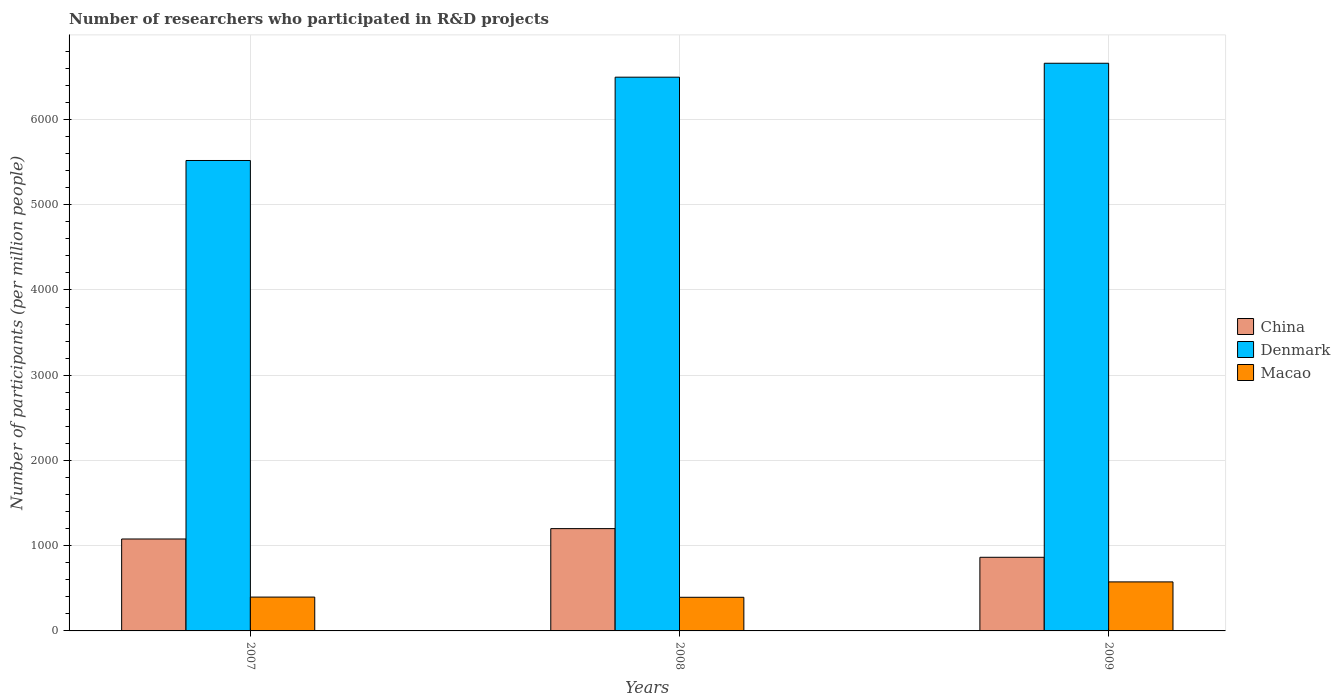How many different coloured bars are there?
Your response must be concise. 3. Are the number of bars on each tick of the X-axis equal?
Offer a terse response. Yes. What is the label of the 2nd group of bars from the left?
Your answer should be compact. 2008. What is the number of researchers who participated in R&D projects in Macao in 2009?
Provide a short and direct response. 575.18. Across all years, what is the maximum number of researchers who participated in R&D projects in China?
Provide a succinct answer. 1200.29. Across all years, what is the minimum number of researchers who participated in R&D projects in China?
Keep it short and to the point. 863.93. In which year was the number of researchers who participated in R&D projects in China maximum?
Make the answer very short. 2008. What is the total number of researchers who participated in R&D projects in Denmark in the graph?
Ensure brevity in your answer.  1.87e+04. What is the difference between the number of researchers who participated in R&D projects in Macao in 2007 and that in 2008?
Your answer should be very brief. 2.28. What is the difference between the number of researchers who participated in R&D projects in China in 2007 and the number of researchers who participated in R&D projects in Macao in 2009?
Keep it short and to the point. 503.45. What is the average number of researchers who participated in R&D projects in China per year?
Give a very brief answer. 1047.62. In the year 2009, what is the difference between the number of researchers who participated in R&D projects in Denmark and number of researchers who participated in R&D projects in China?
Your answer should be very brief. 5796.22. What is the ratio of the number of researchers who participated in R&D projects in China in 2007 to that in 2008?
Keep it short and to the point. 0.9. Is the number of researchers who participated in R&D projects in China in 2007 less than that in 2008?
Make the answer very short. Yes. What is the difference between the highest and the second highest number of researchers who participated in R&D projects in Denmark?
Keep it short and to the point. 163.38. What is the difference between the highest and the lowest number of researchers who participated in R&D projects in China?
Make the answer very short. 336.37. In how many years, is the number of researchers who participated in R&D projects in Denmark greater than the average number of researchers who participated in R&D projects in Denmark taken over all years?
Offer a very short reply. 2. What does the 1st bar from the right in 2007 represents?
Give a very brief answer. Macao. How many bars are there?
Offer a terse response. 9. Are all the bars in the graph horizontal?
Your answer should be compact. No. What is the difference between two consecutive major ticks on the Y-axis?
Provide a succinct answer. 1000. Does the graph contain grids?
Provide a short and direct response. Yes. Where does the legend appear in the graph?
Your answer should be compact. Center right. What is the title of the graph?
Keep it short and to the point. Number of researchers who participated in R&D projects. Does "Kenya" appear as one of the legend labels in the graph?
Offer a terse response. No. What is the label or title of the X-axis?
Offer a very short reply. Years. What is the label or title of the Y-axis?
Provide a short and direct response. Number of participants (per million people). What is the Number of participants (per million people) of China in 2007?
Provide a succinct answer. 1078.63. What is the Number of participants (per million people) in Denmark in 2007?
Make the answer very short. 5519.32. What is the Number of participants (per million people) of Macao in 2007?
Offer a terse response. 396.94. What is the Number of participants (per million people) in China in 2008?
Ensure brevity in your answer.  1200.29. What is the Number of participants (per million people) in Denmark in 2008?
Your answer should be very brief. 6496.76. What is the Number of participants (per million people) in Macao in 2008?
Your answer should be very brief. 394.66. What is the Number of participants (per million people) of China in 2009?
Offer a terse response. 863.93. What is the Number of participants (per million people) of Denmark in 2009?
Give a very brief answer. 6660.14. What is the Number of participants (per million people) in Macao in 2009?
Offer a terse response. 575.18. Across all years, what is the maximum Number of participants (per million people) of China?
Keep it short and to the point. 1200.29. Across all years, what is the maximum Number of participants (per million people) in Denmark?
Keep it short and to the point. 6660.14. Across all years, what is the maximum Number of participants (per million people) in Macao?
Keep it short and to the point. 575.18. Across all years, what is the minimum Number of participants (per million people) of China?
Your response must be concise. 863.93. Across all years, what is the minimum Number of participants (per million people) in Denmark?
Your answer should be very brief. 5519.32. Across all years, what is the minimum Number of participants (per million people) of Macao?
Your response must be concise. 394.66. What is the total Number of participants (per million people) of China in the graph?
Provide a succinct answer. 3142.85. What is the total Number of participants (per million people) of Denmark in the graph?
Your answer should be compact. 1.87e+04. What is the total Number of participants (per million people) in Macao in the graph?
Make the answer very short. 1366.77. What is the difference between the Number of participants (per million people) in China in 2007 and that in 2008?
Make the answer very short. -121.67. What is the difference between the Number of participants (per million people) of Denmark in 2007 and that in 2008?
Make the answer very short. -977.45. What is the difference between the Number of participants (per million people) in Macao in 2007 and that in 2008?
Make the answer very short. 2.28. What is the difference between the Number of participants (per million people) of China in 2007 and that in 2009?
Make the answer very short. 214.7. What is the difference between the Number of participants (per million people) of Denmark in 2007 and that in 2009?
Ensure brevity in your answer.  -1140.83. What is the difference between the Number of participants (per million people) in Macao in 2007 and that in 2009?
Provide a succinct answer. -178.24. What is the difference between the Number of participants (per million people) of China in 2008 and that in 2009?
Your response must be concise. 336.37. What is the difference between the Number of participants (per million people) in Denmark in 2008 and that in 2009?
Give a very brief answer. -163.38. What is the difference between the Number of participants (per million people) of Macao in 2008 and that in 2009?
Offer a very short reply. -180.52. What is the difference between the Number of participants (per million people) of China in 2007 and the Number of participants (per million people) of Denmark in 2008?
Ensure brevity in your answer.  -5418.14. What is the difference between the Number of participants (per million people) in China in 2007 and the Number of participants (per million people) in Macao in 2008?
Provide a short and direct response. 683.97. What is the difference between the Number of participants (per million people) of Denmark in 2007 and the Number of participants (per million people) of Macao in 2008?
Your answer should be compact. 5124.66. What is the difference between the Number of participants (per million people) of China in 2007 and the Number of participants (per million people) of Denmark in 2009?
Your response must be concise. -5581.52. What is the difference between the Number of participants (per million people) of China in 2007 and the Number of participants (per million people) of Macao in 2009?
Your answer should be compact. 503.45. What is the difference between the Number of participants (per million people) of Denmark in 2007 and the Number of participants (per million people) of Macao in 2009?
Your response must be concise. 4944.14. What is the difference between the Number of participants (per million people) of China in 2008 and the Number of participants (per million people) of Denmark in 2009?
Keep it short and to the point. -5459.85. What is the difference between the Number of participants (per million people) in China in 2008 and the Number of participants (per million people) in Macao in 2009?
Your answer should be very brief. 625.12. What is the difference between the Number of participants (per million people) in Denmark in 2008 and the Number of participants (per million people) in Macao in 2009?
Your answer should be compact. 5921.59. What is the average Number of participants (per million people) in China per year?
Your answer should be very brief. 1047.62. What is the average Number of participants (per million people) of Denmark per year?
Provide a succinct answer. 6225.41. What is the average Number of participants (per million people) of Macao per year?
Your answer should be very brief. 455.59. In the year 2007, what is the difference between the Number of participants (per million people) of China and Number of participants (per million people) of Denmark?
Ensure brevity in your answer.  -4440.69. In the year 2007, what is the difference between the Number of participants (per million people) in China and Number of participants (per million people) in Macao?
Give a very brief answer. 681.69. In the year 2007, what is the difference between the Number of participants (per million people) in Denmark and Number of participants (per million people) in Macao?
Offer a terse response. 5122.38. In the year 2008, what is the difference between the Number of participants (per million people) of China and Number of participants (per million people) of Denmark?
Your response must be concise. -5296.47. In the year 2008, what is the difference between the Number of participants (per million people) in China and Number of participants (per million people) in Macao?
Your answer should be very brief. 805.64. In the year 2008, what is the difference between the Number of participants (per million people) in Denmark and Number of participants (per million people) in Macao?
Your answer should be very brief. 6102.1. In the year 2009, what is the difference between the Number of participants (per million people) of China and Number of participants (per million people) of Denmark?
Provide a succinct answer. -5796.22. In the year 2009, what is the difference between the Number of participants (per million people) in China and Number of participants (per million people) in Macao?
Provide a succinct answer. 288.75. In the year 2009, what is the difference between the Number of participants (per million people) in Denmark and Number of participants (per million people) in Macao?
Your response must be concise. 6084.97. What is the ratio of the Number of participants (per million people) of China in 2007 to that in 2008?
Make the answer very short. 0.9. What is the ratio of the Number of participants (per million people) of Denmark in 2007 to that in 2008?
Keep it short and to the point. 0.85. What is the ratio of the Number of participants (per million people) of China in 2007 to that in 2009?
Ensure brevity in your answer.  1.25. What is the ratio of the Number of participants (per million people) of Denmark in 2007 to that in 2009?
Provide a short and direct response. 0.83. What is the ratio of the Number of participants (per million people) in Macao in 2007 to that in 2009?
Make the answer very short. 0.69. What is the ratio of the Number of participants (per million people) of China in 2008 to that in 2009?
Your answer should be very brief. 1.39. What is the ratio of the Number of participants (per million people) of Denmark in 2008 to that in 2009?
Make the answer very short. 0.98. What is the ratio of the Number of participants (per million people) in Macao in 2008 to that in 2009?
Provide a short and direct response. 0.69. What is the difference between the highest and the second highest Number of participants (per million people) in China?
Give a very brief answer. 121.67. What is the difference between the highest and the second highest Number of participants (per million people) in Denmark?
Provide a succinct answer. 163.38. What is the difference between the highest and the second highest Number of participants (per million people) in Macao?
Ensure brevity in your answer.  178.24. What is the difference between the highest and the lowest Number of participants (per million people) in China?
Offer a very short reply. 336.37. What is the difference between the highest and the lowest Number of participants (per million people) of Denmark?
Give a very brief answer. 1140.83. What is the difference between the highest and the lowest Number of participants (per million people) of Macao?
Provide a succinct answer. 180.52. 